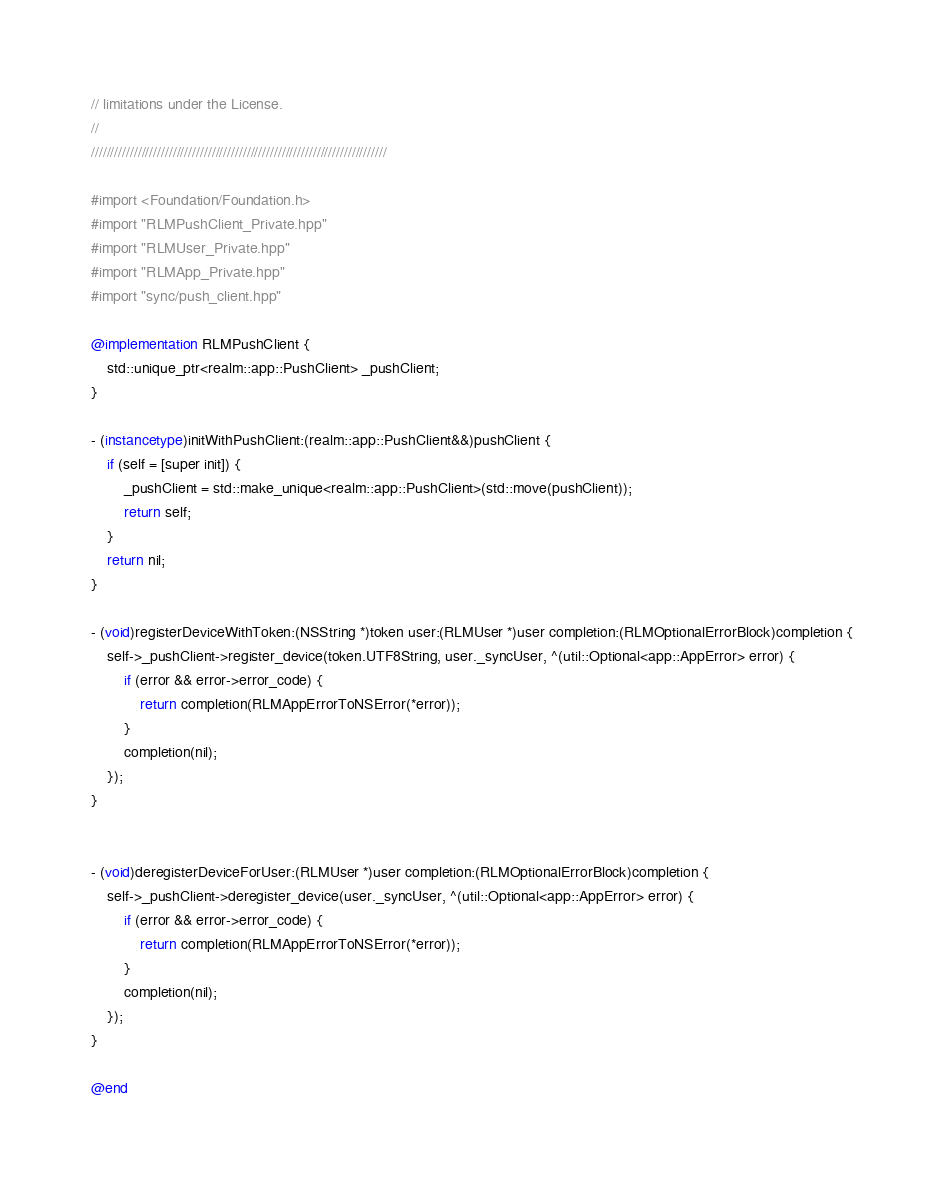Convert code to text. <code><loc_0><loc_0><loc_500><loc_500><_ObjectiveC_>// limitations under the License.
//
////////////////////////////////////////////////////////////////////////////

#import <Foundation/Foundation.h>
#import "RLMPushClient_Private.hpp"
#import "RLMUser_Private.hpp"
#import "RLMApp_Private.hpp"
#import "sync/push_client.hpp"

@implementation RLMPushClient {
    std::unique_ptr<realm::app::PushClient> _pushClient;
}

- (instancetype)initWithPushClient:(realm::app::PushClient&&)pushClient {
    if (self = [super init]) {
        _pushClient = std::make_unique<realm::app::PushClient>(std::move(pushClient));
        return self;
    }
    return nil;
}

- (void)registerDeviceWithToken:(NSString *)token user:(RLMUser *)user completion:(RLMOptionalErrorBlock)completion {
    self->_pushClient->register_device(token.UTF8String, user._syncUser, ^(util::Optional<app::AppError> error) {
        if (error && error->error_code) {
            return completion(RLMAppErrorToNSError(*error));
        }
        completion(nil);
    });
}


- (void)deregisterDeviceForUser:(RLMUser *)user completion:(RLMOptionalErrorBlock)completion {
    self->_pushClient->deregister_device(user._syncUser, ^(util::Optional<app::AppError> error) {
        if (error && error->error_code) {
            return completion(RLMAppErrorToNSError(*error));
        }
        completion(nil);
    });
}

@end
</code> 